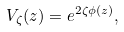Convert formula to latex. <formula><loc_0><loc_0><loc_500><loc_500>V _ { \zeta } ( z ) = e ^ { 2 \zeta \phi ( z ) } ,</formula> 